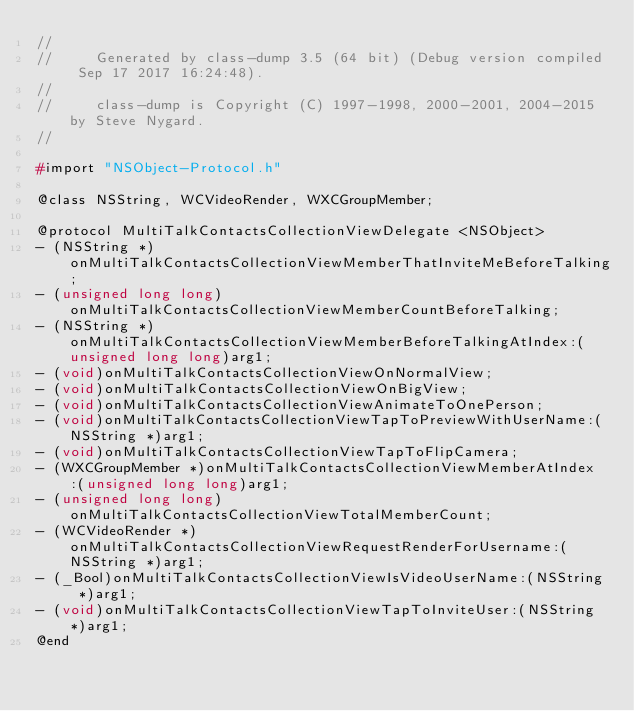<code> <loc_0><loc_0><loc_500><loc_500><_C_>//
//     Generated by class-dump 3.5 (64 bit) (Debug version compiled Sep 17 2017 16:24:48).
//
//     class-dump is Copyright (C) 1997-1998, 2000-2001, 2004-2015 by Steve Nygard.
//

#import "NSObject-Protocol.h"

@class NSString, WCVideoRender, WXCGroupMember;

@protocol MultiTalkContactsCollectionViewDelegate <NSObject>
- (NSString *)onMultiTalkContactsCollectionViewMemberThatInviteMeBeforeTalking;
- (unsigned long long)onMultiTalkContactsCollectionViewMemberCountBeforeTalking;
- (NSString *)onMultiTalkContactsCollectionViewMemberBeforeTalkingAtIndex:(unsigned long long)arg1;
- (void)onMultiTalkContactsCollectionViewOnNormalView;
- (void)onMultiTalkContactsCollectionViewOnBigView;
- (void)onMultiTalkContactsCollectionViewAnimateToOnePerson;
- (void)onMultiTalkContactsCollectionViewTapToPreviewWithUserName:(NSString *)arg1;
- (void)onMultiTalkContactsCollectionViewTapToFlipCamera;
- (WXCGroupMember *)onMultiTalkContactsCollectionViewMemberAtIndex:(unsigned long long)arg1;
- (unsigned long long)onMultiTalkContactsCollectionViewTotalMemberCount;
- (WCVideoRender *)onMultiTalkContactsCollectionViewRequestRenderForUsername:(NSString *)arg1;
- (_Bool)onMultiTalkContactsCollectionViewIsVideoUserName:(NSString *)arg1;
- (void)onMultiTalkContactsCollectionViewTapToInviteUser:(NSString *)arg1;
@end

</code> 